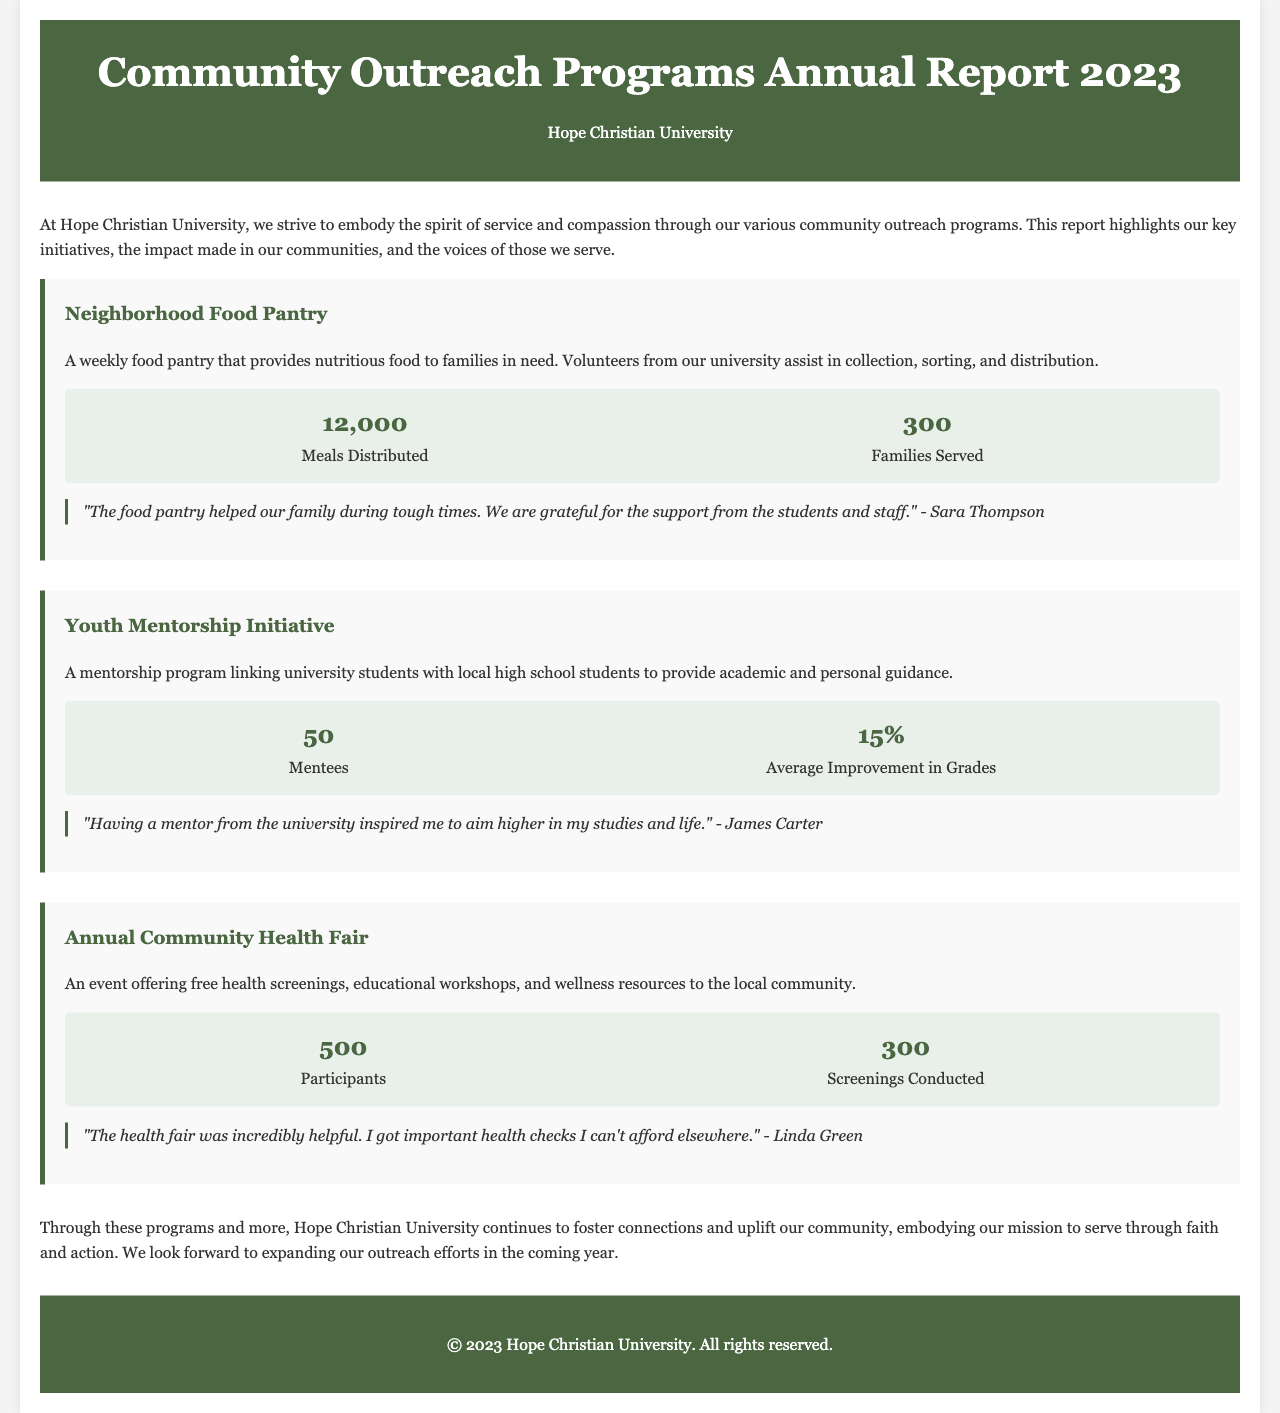What is the title of the report? The title of the report is clearly stated in the header section of the document.
Answer: Community Outreach Programs Annual Report 2023 How many meals were distributed by the Neighborhood Food Pantry? This information can be found in the metrics section for the Neighborhood Food Pantry program.
Answer: 12,000 What percentage of average improvement in grades was reported in the Youth Mentorship Initiative? The average improvement in grades is mentioned in the metrics section for the Youth Mentorship Initiative.
Answer: 15% Who expressed gratitude for the food pantry? The testimonial in the Neighborhood Food Pantry section provides the name of the person who expressed gratitude.
Answer: Sara Thompson How many participants attended the Annual Community Health Fair? This number is provided in the metrics section for the Annual Community Health Fair program.
Answer: 500 What is the primary purpose of the Youth Mentorship Initiative? The reason for establishing the Youth Mentorship Initiative is outlined in the description of the program.
Answer: Academic and personal guidance What type of resource was offered at the Annual Community Health Fair? The health fair's offerings are detailed in the description of the event, specifying the type of resources provided.
Answer: Health screenings Which program helped families in need? The specific program aimed at aiding families is mentioned in the document.
Answer: Neighborhood Food Pantry 